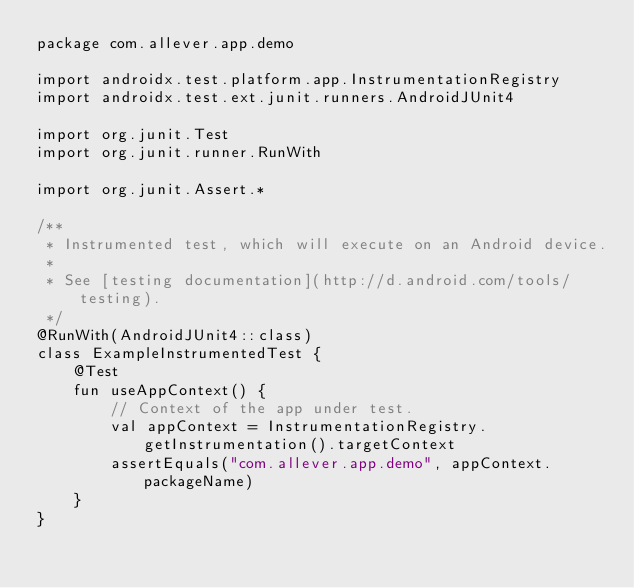<code> <loc_0><loc_0><loc_500><loc_500><_Kotlin_>package com.allever.app.demo

import androidx.test.platform.app.InstrumentationRegistry
import androidx.test.ext.junit.runners.AndroidJUnit4

import org.junit.Test
import org.junit.runner.RunWith

import org.junit.Assert.*

/**
 * Instrumented test, which will execute on an Android device.
 *
 * See [testing documentation](http://d.android.com/tools/testing).
 */
@RunWith(AndroidJUnit4::class)
class ExampleInstrumentedTest {
    @Test
    fun useAppContext() {
        // Context of the app under test.
        val appContext = InstrumentationRegistry.getInstrumentation().targetContext
        assertEquals("com.allever.app.demo", appContext.packageName)
    }
}</code> 